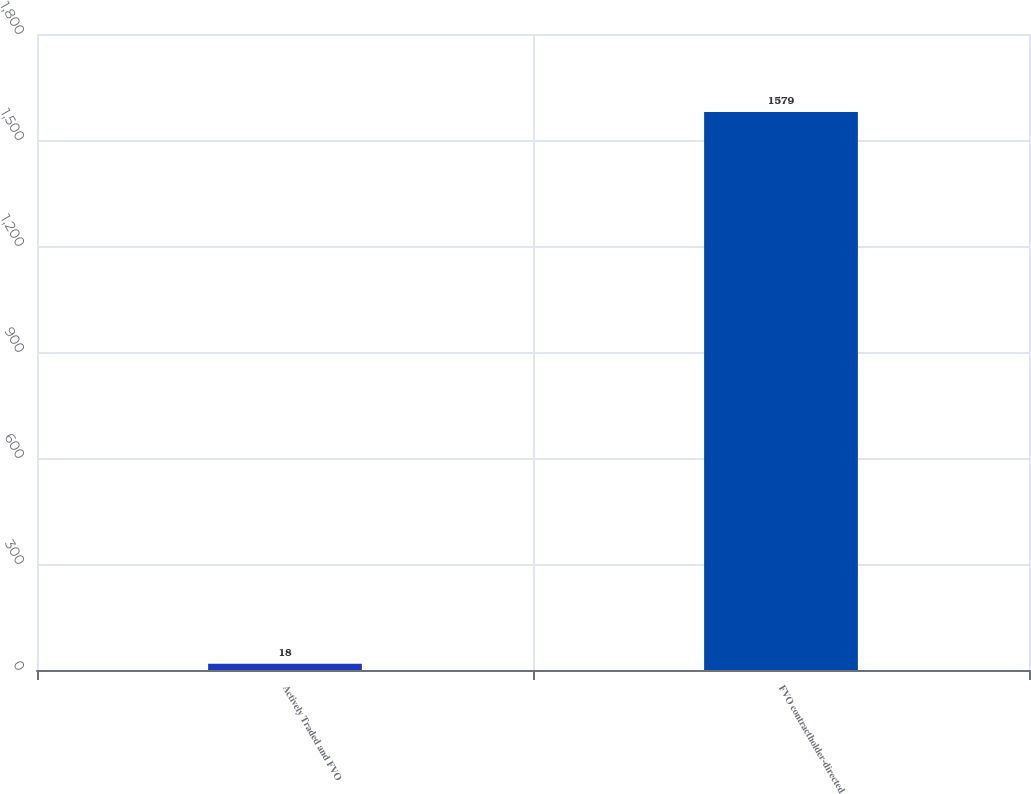<chart> <loc_0><loc_0><loc_500><loc_500><bar_chart><fcel>Actively Traded and FVO<fcel>FVO contractholder-directed<nl><fcel>18<fcel>1579<nl></chart> 